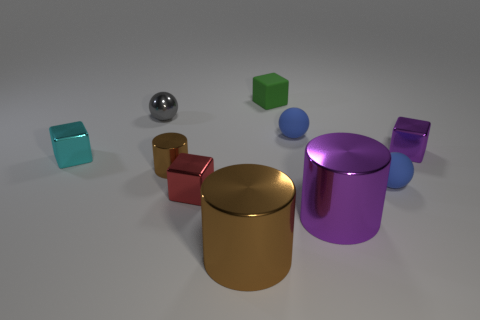How many tiny things are left of the purple thing in front of the tiny cyan block on the left side of the large brown shiny object?
Your answer should be compact. 6. Are there any other things that have the same color as the matte cube?
Offer a terse response. No. There is a metal object that is in front of the large purple metallic cylinder; is it the same color as the ball that is in front of the small brown thing?
Your answer should be very brief. No. Is the number of small red blocks behind the gray metal thing greater than the number of tiny metal blocks that are in front of the large purple thing?
Offer a terse response. No. What is the red block made of?
Offer a very short reply. Metal. The tiny metal thing that is on the right side of the matte object behind the small blue matte ball behind the small brown cylinder is what shape?
Offer a terse response. Cube. What number of other objects are the same material as the tiny purple cube?
Provide a short and direct response. 6. Are the blue sphere that is in front of the small brown shiny cylinder and the large object to the right of the big brown metallic thing made of the same material?
Offer a terse response. No. What number of metal things are both on the right side of the tiny gray thing and behind the small purple metal block?
Offer a very short reply. 0. Is there a tiny cyan thing of the same shape as the gray object?
Keep it short and to the point. No. 